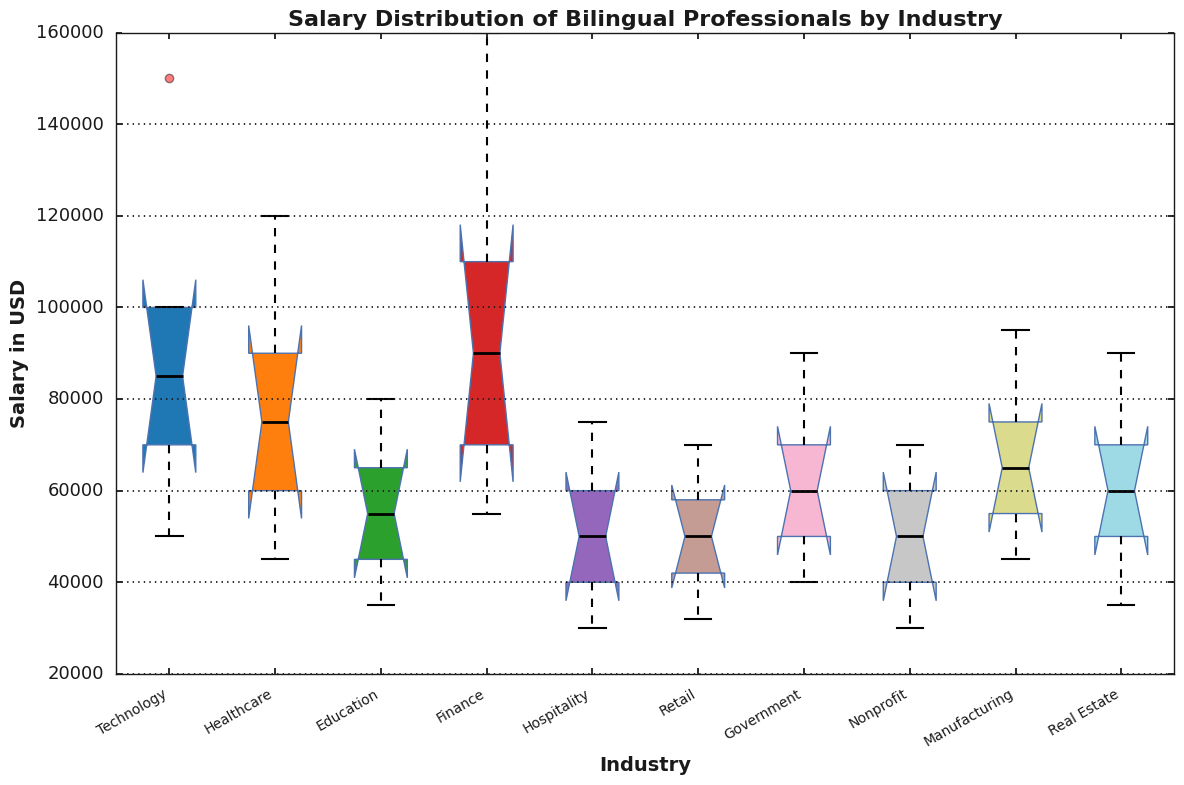What is the median salary for bilingual professionals in the Technology industry? The median salary for the Technology industry is visually denoted by the thick black line inside the corresponding box. For Technology, it is located at $85,000.
Answer: $85,000 Which industry has the highest maximum salary? The highest maximum salary is illustrated by the upper whisker of each box plot. The Finance industry has the highest maximum salary at $160,000.
Answer: Finance What’s the range of salaries in the Education industry? The range is calculated by subtracting the minimum salary from the maximum salary. For Education, the range is $80,000 - $35,000 = $45,000.
Answer: $45,000 Which industry has the smallest interquartile range (IQR)? The IQR is the difference between Q3 (the upper edge of the box) and Q1 (the lower edge of the box). The industry with the smallest IQR can be identified by the smallest height of the box. The Government industry has the smallest IQR.
Answer: Government Which industries have a minimum salary at or below $35,000? The minimum salary is represented by the lower whisker. The industries with minimum salaries at or below $35,000 are Education, Hospitality, Nonprofit, and Real Estate.
Answer: Education, Hospitality, Nonprofit, Real Estate How does the median salary of the Finance industry compare with that of Healthcare? Comparing the thick black lines inside each box, the median salary of the Finance industry ($90,000) is higher than that of Healthcare ($75,000).
Answer: Finance’s median is higher What is the approximate IQR for the Manufacturing industry? The IQR is the difference between Q3 and Q1. For the Manufacturing industry, Q3 is $75,000 and Q1 is $55,000, making the IQR $75,000 - $55,000 = $20,000.
Answer: $20,000 Which industry has both its Q1 and Q3 values below $60,000? Identifying the positions of Q1 and Q3 for each box, Hospitality and Retail fit this criterion, with both Q1 and Q3 below $60,000.
Answer: Hospitality, Retail Which industry’s median salary is closest to the median salary of Government? The median salary of the Government industry is $60,000. Comparing medians across industries, the Real Estate industry's median ($60,000) is the exact match to Government.
Answer: Real Estate 